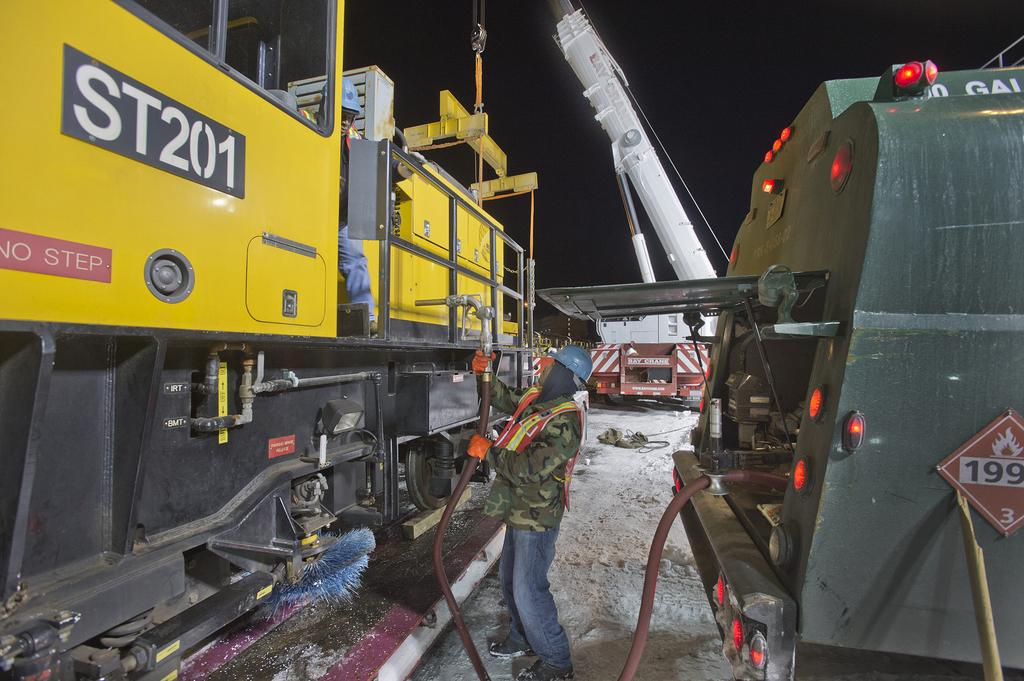<image>
Create a compact narrative representing the image presented. A worker with a blue helmet is aiming a hose toward a large yellow machine that has ST201 on the side. 